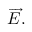<formula> <loc_0><loc_0><loc_500><loc_500>{ \overrightarrow { E } } .</formula> 